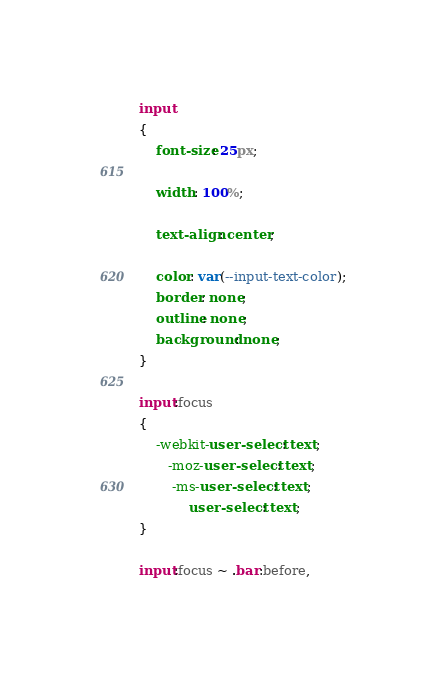Convert code to text. <code><loc_0><loc_0><loc_500><loc_500><_CSS_>input
{
    font-size: 25px;

    width: 100%;

    text-align: center;

    color: var(--input-text-color);
    border: none;
    outline: none;
    background: none;
}

input:focus
{
    -webkit-user-select: text;
       -moz-user-select: text;
        -ms-user-select: text;
            user-select: text;
}

input:focus ~ .bar:before,</code> 